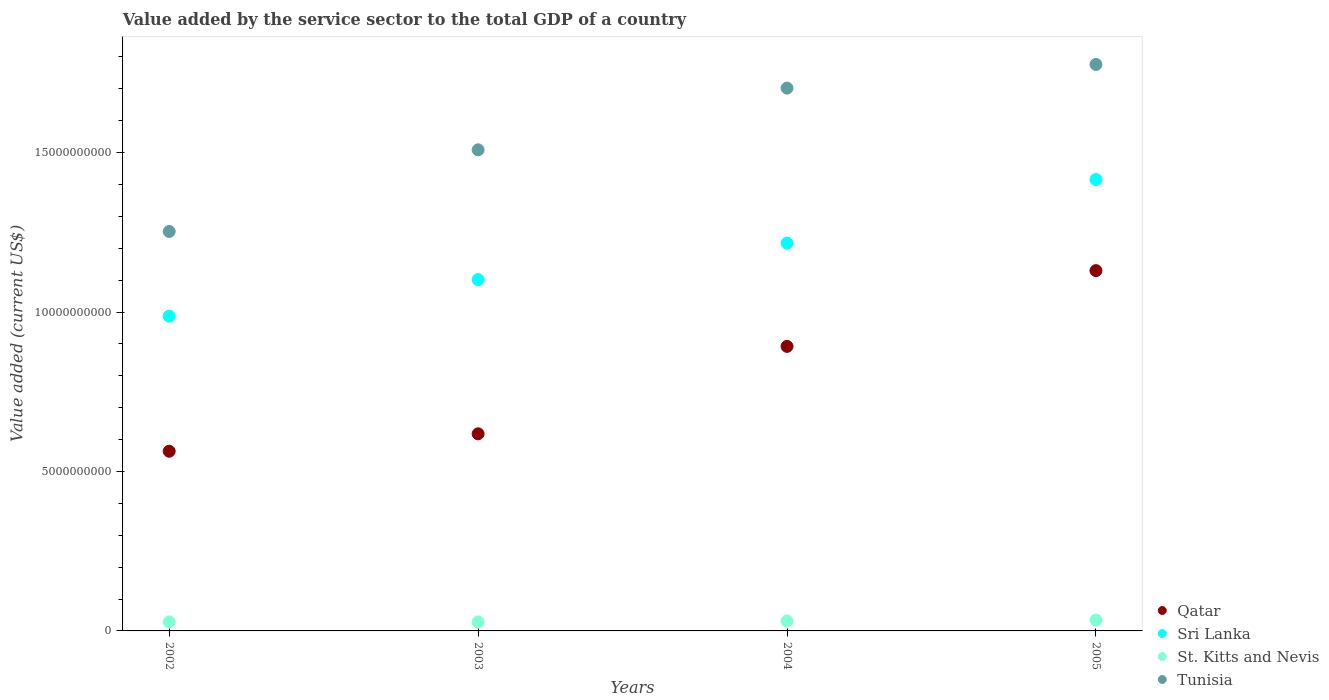How many different coloured dotlines are there?
Give a very brief answer. 4. What is the value added by the service sector to the total GDP in Sri Lanka in 2004?
Provide a succinct answer. 1.22e+1. Across all years, what is the maximum value added by the service sector to the total GDP in Qatar?
Your answer should be very brief. 1.13e+1. Across all years, what is the minimum value added by the service sector to the total GDP in St. Kitts and Nevis?
Make the answer very short. 2.83e+08. In which year was the value added by the service sector to the total GDP in St. Kitts and Nevis minimum?
Keep it short and to the point. 2002. What is the total value added by the service sector to the total GDP in Sri Lanka in the graph?
Your response must be concise. 4.72e+1. What is the difference between the value added by the service sector to the total GDP in St. Kitts and Nevis in 2004 and that in 2005?
Your answer should be compact. -2.75e+07. What is the difference between the value added by the service sector to the total GDP in Tunisia in 2004 and the value added by the service sector to the total GDP in Qatar in 2003?
Give a very brief answer. 1.08e+1. What is the average value added by the service sector to the total GDP in Sri Lanka per year?
Keep it short and to the point. 1.18e+1. In the year 2004, what is the difference between the value added by the service sector to the total GDP in St. Kitts and Nevis and value added by the service sector to the total GDP in Tunisia?
Offer a terse response. -1.67e+1. In how many years, is the value added by the service sector to the total GDP in St. Kitts and Nevis greater than 8000000000 US$?
Keep it short and to the point. 0. What is the ratio of the value added by the service sector to the total GDP in Sri Lanka in 2003 to that in 2005?
Your answer should be compact. 0.78. Is the value added by the service sector to the total GDP in Qatar in 2002 less than that in 2005?
Provide a short and direct response. Yes. What is the difference between the highest and the second highest value added by the service sector to the total GDP in St. Kitts and Nevis?
Your response must be concise. 2.75e+07. What is the difference between the highest and the lowest value added by the service sector to the total GDP in Qatar?
Make the answer very short. 5.66e+09. In how many years, is the value added by the service sector to the total GDP in Tunisia greater than the average value added by the service sector to the total GDP in Tunisia taken over all years?
Make the answer very short. 2. Is the value added by the service sector to the total GDP in Qatar strictly less than the value added by the service sector to the total GDP in Tunisia over the years?
Give a very brief answer. Yes. How many years are there in the graph?
Ensure brevity in your answer.  4. Does the graph contain any zero values?
Your answer should be compact. No. Does the graph contain grids?
Ensure brevity in your answer.  No. Where does the legend appear in the graph?
Your answer should be compact. Bottom right. How many legend labels are there?
Keep it short and to the point. 4. How are the legend labels stacked?
Offer a terse response. Vertical. What is the title of the graph?
Your answer should be compact. Value added by the service sector to the total GDP of a country. What is the label or title of the X-axis?
Your response must be concise. Years. What is the label or title of the Y-axis?
Ensure brevity in your answer.  Value added (current US$). What is the Value added (current US$) of Qatar in 2002?
Provide a succinct answer. 5.63e+09. What is the Value added (current US$) of Sri Lanka in 2002?
Your response must be concise. 9.87e+09. What is the Value added (current US$) in St. Kitts and Nevis in 2002?
Offer a very short reply. 2.83e+08. What is the Value added (current US$) of Tunisia in 2002?
Your response must be concise. 1.25e+1. What is the Value added (current US$) of Qatar in 2003?
Keep it short and to the point. 6.18e+09. What is the Value added (current US$) in Sri Lanka in 2003?
Keep it short and to the point. 1.10e+1. What is the Value added (current US$) in St. Kitts and Nevis in 2003?
Give a very brief answer. 2.83e+08. What is the Value added (current US$) in Tunisia in 2003?
Provide a succinct answer. 1.51e+1. What is the Value added (current US$) of Qatar in 2004?
Provide a short and direct response. 8.92e+09. What is the Value added (current US$) in Sri Lanka in 2004?
Provide a succinct answer. 1.22e+1. What is the Value added (current US$) of St. Kitts and Nevis in 2004?
Ensure brevity in your answer.  3.12e+08. What is the Value added (current US$) in Tunisia in 2004?
Offer a very short reply. 1.70e+1. What is the Value added (current US$) of Qatar in 2005?
Give a very brief answer. 1.13e+1. What is the Value added (current US$) in Sri Lanka in 2005?
Keep it short and to the point. 1.42e+1. What is the Value added (current US$) in St. Kitts and Nevis in 2005?
Offer a terse response. 3.39e+08. What is the Value added (current US$) of Tunisia in 2005?
Provide a short and direct response. 1.78e+1. Across all years, what is the maximum Value added (current US$) in Qatar?
Give a very brief answer. 1.13e+1. Across all years, what is the maximum Value added (current US$) in Sri Lanka?
Offer a very short reply. 1.42e+1. Across all years, what is the maximum Value added (current US$) of St. Kitts and Nevis?
Keep it short and to the point. 3.39e+08. Across all years, what is the maximum Value added (current US$) in Tunisia?
Keep it short and to the point. 1.78e+1. Across all years, what is the minimum Value added (current US$) of Qatar?
Give a very brief answer. 5.63e+09. Across all years, what is the minimum Value added (current US$) of Sri Lanka?
Offer a very short reply. 9.87e+09. Across all years, what is the minimum Value added (current US$) of St. Kitts and Nevis?
Your answer should be very brief. 2.83e+08. Across all years, what is the minimum Value added (current US$) of Tunisia?
Your answer should be compact. 1.25e+1. What is the total Value added (current US$) in Qatar in the graph?
Offer a very short reply. 3.20e+1. What is the total Value added (current US$) in Sri Lanka in the graph?
Provide a succinct answer. 4.72e+1. What is the total Value added (current US$) in St. Kitts and Nevis in the graph?
Your response must be concise. 1.22e+09. What is the total Value added (current US$) in Tunisia in the graph?
Make the answer very short. 6.24e+1. What is the difference between the Value added (current US$) of Qatar in 2002 and that in 2003?
Give a very brief answer. -5.47e+08. What is the difference between the Value added (current US$) in Sri Lanka in 2002 and that in 2003?
Offer a very short reply. -1.15e+09. What is the difference between the Value added (current US$) of St. Kitts and Nevis in 2002 and that in 2003?
Your answer should be compact. -1.73e+05. What is the difference between the Value added (current US$) in Tunisia in 2002 and that in 2003?
Keep it short and to the point. -2.56e+09. What is the difference between the Value added (current US$) in Qatar in 2002 and that in 2004?
Make the answer very short. -3.29e+09. What is the difference between the Value added (current US$) in Sri Lanka in 2002 and that in 2004?
Keep it short and to the point. -2.29e+09. What is the difference between the Value added (current US$) of St. Kitts and Nevis in 2002 and that in 2004?
Your answer should be very brief. -2.91e+07. What is the difference between the Value added (current US$) of Tunisia in 2002 and that in 2004?
Offer a very short reply. -4.50e+09. What is the difference between the Value added (current US$) in Qatar in 2002 and that in 2005?
Make the answer very short. -5.66e+09. What is the difference between the Value added (current US$) of Sri Lanka in 2002 and that in 2005?
Offer a terse response. -4.28e+09. What is the difference between the Value added (current US$) in St. Kitts and Nevis in 2002 and that in 2005?
Your answer should be very brief. -5.65e+07. What is the difference between the Value added (current US$) in Tunisia in 2002 and that in 2005?
Keep it short and to the point. -5.24e+09. What is the difference between the Value added (current US$) in Qatar in 2003 and that in 2004?
Your answer should be very brief. -2.74e+09. What is the difference between the Value added (current US$) of Sri Lanka in 2003 and that in 2004?
Make the answer very short. -1.14e+09. What is the difference between the Value added (current US$) of St. Kitts and Nevis in 2003 and that in 2004?
Your response must be concise. -2.89e+07. What is the difference between the Value added (current US$) in Tunisia in 2003 and that in 2004?
Your answer should be very brief. -1.94e+09. What is the difference between the Value added (current US$) in Qatar in 2003 and that in 2005?
Offer a very short reply. -5.12e+09. What is the difference between the Value added (current US$) in Sri Lanka in 2003 and that in 2005?
Give a very brief answer. -3.14e+09. What is the difference between the Value added (current US$) of St. Kitts and Nevis in 2003 and that in 2005?
Provide a succinct answer. -5.64e+07. What is the difference between the Value added (current US$) in Tunisia in 2003 and that in 2005?
Give a very brief answer. -2.68e+09. What is the difference between the Value added (current US$) of Qatar in 2004 and that in 2005?
Provide a short and direct response. -2.38e+09. What is the difference between the Value added (current US$) of Sri Lanka in 2004 and that in 2005?
Your answer should be compact. -2.00e+09. What is the difference between the Value added (current US$) of St. Kitts and Nevis in 2004 and that in 2005?
Provide a short and direct response. -2.75e+07. What is the difference between the Value added (current US$) in Tunisia in 2004 and that in 2005?
Your answer should be compact. -7.42e+08. What is the difference between the Value added (current US$) in Qatar in 2002 and the Value added (current US$) in Sri Lanka in 2003?
Give a very brief answer. -5.38e+09. What is the difference between the Value added (current US$) of Qatar in 2002 and the Value added (current US$) of St. Kitts and Nevis in 2003?
Provide a short and direct response. 5.35e+09. What is the difference between the Value added (current US$) of Qatar in 2002 and the Value added (current US$) of Tunisia in 2003?
Your answer should be very brief. -9.45e+09. What is the difference between the Value added (current US$) of Sri Lanka in 2002 and the Value added (current US$) of St. Kitts and Nevis in 2003?
Your response must be concise. 9.59e+09. What is the difference between the Value added (current US$) in Sri Lanka in 2002 and the Value added (current US$) in Tunisia in 2003?
Your answer should be compact. -5.22e+09. What is the difference between the Value added (current US$) of St. Kitts and Nevis in 2002 and the Value added (current US$) of Tunisia in 2003?
Your answer should be compact. -1.48e+1. What is the difference between the Value added (current US$) in Qatar in 2002 and the Value added (current US$) in Sri Lanka in 2004?
Give a very brief answer. -6.52e+09. What is the difference between the Value added (current US$) of Qatar in 2002 and the Value added (current US$) of St. Kitts and Nevis in 2004?
Ensure brevity in your answer.  5.32e+09. What is the difference between the Value added (current US$) of Qatar in 2002 and the Value added (current US$) of Tunisia in 2004?
Keep it short and to the point. -1.14e+1. What is the difference between the Value added (current US$) in Sri Lanka in 2002 and the Value added (current US$) in St. Kitts and Nevis in 2004?
Make the answer very short. 9.56e+09. What is the difference between the Value added (current US$) of Sri Lanka in 2002 and the Value added (current US$) of Tunisia in 2004?
Your answer should be compact. -7.15e+09. What is the difference between the Value added (current US$) of St. Kitts and Nevis in 2002 and the Value added (current US$) of Tunisia in 2004?
Provide a succinct answer. -1.67e+1. What is the difference between the Value added (current US$) in Qatar in 2002 and the Value added (current US$) in Sri Lanka in 2005?
Offer a terse response. -8.52e+09. What is the difference between the Value added (current US$) in Qatar in 2002 and the Value added (current US$) in St. Kitts and Nevis in 2005?
Provide a short and direct response. 5.29e+09. What is the difference between the Value added (current US$) in Qatar in 2002 and the Value added (current US$) in Tunisia in 2005?
Provide a short and direct response. -1.21e+1. What is the difference between the Value added (current US$) of Sri Lanka in 2002 and the Value added (current US$) of St. Kitts and Nevis in 2005?
Provide a short and direct response. 9.53e+09. What is the difference between the Value added (current US$) in Sri Lanka in 2002 and the Value added (current US$) in Tunisia in 2005?
Your response must be concise. -7.89e+09. What is the difference between the Value added (current US$) in St. Kitts and Nevis in 2002 and the Value added (current US$) in Tunisia in 2005?
Your response must be concise. -1.75e+1. What is the difference between the Value added (current US$) in Qatar in 2003 and the Value added (current US$) in Sri Lanka in 2004?
Ensure brevity in your answer.  -5.98e+09. What is the difference between the Value added (current US$) of Qatar in 2003 and the Value added (current US$) of St. Kitts and Nevis in 2004?
Keep it short and to the point. 5.87e+09. What is the difference between the Value added (current US$) in Qatar in 2003 and the Value added (current US$) in Tunisia in 2004?
Offer a very short reply. -1.08e+1. What is the difference between the Value added (current US$) of Sri Lanka in 2003 and the Value added (current US$) of St. Kitts and Nevis in 2004?
Give a very brief answer. 1.07e+1. What is the difference between the Value added (current US$) of Sri Lanka in 2003 and the Value added (current US$) of Tunisia in 2004?
Your answer should be very brief. -6.00e+09. What is the difference between the Value added (current US$) in St. Kitts and Nevis in 2003 and the Value added (current US$) in Tunisia in 2004?
Offer a very short reply. -1.67e+1. What is the difference between the Value added (current US$) of Qatar in 2003 and the Value added (current US$) of Sri Lanka in 2005?
Provide a short and direct response. -7.97e+09. What is the difference between the Value added (current US$) in Qatar in 2003 and the Value added (current US$) in St. Kitts and Nevis in 2005?
Offer a very short reply. 5.84e+09. What is the difference between the Value added (current US$) in Qatar in 2003 and the Value added (current US$) in Tunisia in 2005?
Offer a terse response. -1.16e+1. What is the difference between the Value added (current US$) in Sri Lanka in 2003 and the Value added (current US$) in St. Kitts and Nevis in 2005?
Your answer should be compact. 1.07e+1. What is the difference between the Value added (current US$) of Sri Lanka in 2003 and the Value added (current US$) of Tunisia in 2005?
Give a very brief answer. -6.75e+09. What is the difference between the Value added (current US$) of St. Kitts and Nevis in 2003 and the Value added (current US$) of Tunisia in 2005?
Make the answer very short. -1.75e+1. What is the difference between the Value added (current US$) in Qatar in 2004 and the Value added (current US$) in Sri Lanka in 2005?
Provide a short and direct response. -5.23e+09. What is the difference between the Value added (current US$) of Qatar in 2004 and the Value added (current US$) of St. Kitts and Nevis in 2005?
Your answer should be very brief. 8.58e+09. What is the difference between the Value added (current US$) of Qatar in 2004 and the Value added (current US$) of Tunisia in 2005?
Make the answer very short. -8.84e+09. What is the difference between the Value added (current US$) of Sri Lanka in 2004 and the Value added (current US$) of St. Kitts and Nevis in 2005?
Make the answer very short. 1.18e+1. What is the difference between the Value added (current US$) in Sri Lanka in 2004 and the Value added (current US$) in Tunisia in 2005?
Your response must be concise. -5.61e+09. What is the difference between the Value added (current US$) of St. Kitts and Nevis in 2004 and the Value added (current US$) of Tunisia in 2005?
Your response must be concise. -1.75e+1. What is the average Value added (current US$) of Qatar per year?
Provide a succinct answer. 8.01e+09. What is the average Value added (current US$) of Sri Lanka per year?
Offer a very short reply. 1.18e+1. What is the average Value added (current US$) of St. Kitts and Nevis per year?
Give a very brief answer. 3.04e+08. What is the average Value added (current US$) of Tunisia per year?
Offer a terse response. 1.56e+1. In the year 2002, what is the difference between the Value added (current US$) of Qatar and Value added (current US$) of Sri Lanka?
Your answer should be compact. -4.24e+09. In the year 2002, what is the difference between the Value added (current US$) of Qatar and Value added (current US$) of St. Kitts and Nevis?
Your response must be concise. 5.35e+09. In the year 2002, what is the difference between the Value added (current US$) of Qatar and Value added (current US$) of Tunisia?
Offer a very short reply. -6.89e+09. In the year 2002, what is the difference between the Value added (current US$) of Sri Lanka and Value added (current US$) of St. Kitts and Nevis?
Keep it short and to the point. 9.59e+09. In the year 2002, what is the difference between the Value added (current US$) of Sri Lanka and Value added (current US$) of Tunisia?
Provide a short and direct response. -2.66e+09. In the year 2002, what is the difference between the Value added (current US$) in St. Kitts and Nevis and Value added (current US$) in Tunisia?
Offer a very short reply. -1.22e+1. In the year 2003, what is the difference between the Value added (current US$) in Qatar and Value added (current US$) in Sri Lanka?
Provide a succinct answer. -4.84e+09. In the year 2003, what is the difference between the Value added (current US$) of Qatar and Value added (current US$) of St. Kitts and Nevis?
Offer a terse response. 5.90e+09. In the year 2003, what is the difference between the Value added (current US$) in Qatar and Value added (current US$) in Tunisia?
Your answer should be compact. -8.90e+09. In the year 2003, what is the difference between the Value added (current US$) of Sri Lanka and Value added (current US$) of St. Kitts and Nevis?
Your answer should be compact. 1.07e+1. In the year 2003, what is the difference between the Value added (current US$) of Sri Lanka and Value added (current US$) of Tunisia?
Your answer should be very brief. -4.07e+09. In the year 2003, what is the difference between the Value added (current US$) of St. Kitts and Nevis and Value added (current US$) of Tunisia?
Make the answer very short. -1.48e+1. In the year 2004, what is the difference between the Value added (current US$) in Qatar and Value added (current US$) in Sri Lanka?
Offer a very short reply. -3.24e+09. In the year 2004, what is the difference between the Value added (current US$) of Qatar and Value added (current US$) of St. Kitts and Nevis?
Give a very brief answer. 8.61e+09. In the year 2004, what is the difference between the Value added (current US$) of Qatar and Value added (current US$) of Tunisia?
Your answer should be compact. -8.10e+09. In the year 2004, what is the difference between the Value added (current US$) in Sri Lanka and Value added (current US$) in St. Kitts and Nevis?
Provide a succinct answer. 1.18e+1. In the year 2004, what is the difference between the Value added (current US$) of Sri Lanka and Value added (current US$) of Tunisia?
Offer a very short reply. -4.86e+09. In the year 2004, what is the difference between the Value added (current US$) in St. Kitts and Nevis and Value added (current US$) in Tunisia?
Make the answer very short. -1.67e+1. In the year 2005, what is the difference between the Value added (current US$) in Qatar and Value added (current US$) in Sri Lanka?
Keep it short and to the point. -2.86e+09. In the year 2005, what is the difference between the Value added (current US$) of Qatar and Value added (current US$) of St. Kitts and Nevis?
Provide a succinct answer. 1.10e+1. In the year 2005, what is the difference between the Value added (current US$) in Qatar and Value added (current US$) in Tunisia?
Ensure brevity in your answer.  -6.47e+09. In the year 2005, what is the difference between the Value added (current US$) in Sri Lanka and Value added (current US$) in St. Kitts and Nevis?
Ensure brevity in your answer.  1.38e+1. In the year 2005, what is the difference between the Value added (current US$) of Sri Lanka and Value added (current US$) of Tunisia?
Offer a terse response. -3.61e+09. In the year 2005, what is the difference between the Value added (current US$) in St. Kitts and Nevis and Value added (current US$) in Tunisia?
Provide a succinct answer. -1.74e+1. What is the ratio of the Value added (current US$) in Qatar in 2002 to that in 2003?
Your response must be concise. 0.91. What is the ratio of the Value added (current US$) of Sri Lanka in 2002 to that in 2003?
Keep it short and to the point. 0.9. What is the ratio of the Value added (current US$) in St. Kitts and Nevis in 2002 to that in 2003?
Offer a terse response. 1. What is the ratio of the Value added (current US$) in Tunisia in 2002 to that in 2003?
Make the answer very short. 0.83. What is the ratio of the Value added (current US$) in Qatar in 2002 to that in 2004?
Give a very brief answer. 0.63. What is the ratio of the Value added (current US$) in Sri Lanka in 2002 to that in 2004?
Your answer should be very brief. 0.81. What is the ratio of the Value added (current US$) of St. Kitts and Nevis in 2002 to that in 2004?
Offer a very short reply. 0.91. What is the ratio of the Value added (current US$) in Tunisia in 2002 to that in 2004?
Provide a succinct answer. 0.74. What is the ratio of the Value added (current US$) of Qatar in 2002 to that in 2005?
Make the answer very short. 0.5. What is the ratio of the Value added (current US$) in Sri Lanka in 2002 to that in 2005?
Keep it short and to the point. 0.7. What is the ratio of the Value added (current US$) of St. Kitts and Nevis in 2002 to that in 2005?
Provide a succinct answer. 0.83. What is the ratio of the Value added (current US$) in Tunisia in 2002 to that in 2005?
Keep it short and to the point. 0.71. What is the ratio of the Value added (current US$) of Qatar in 2003 to that in 2004?
Provide a short and direct response. 0.69. What is the ratio of the Value added (current US$) in Sri Lanka in 2003 to that in 2004?
Your answer should be very brief. 0.91. What is the ratio of the Value added (current US$) in St. Kitts and Nevis in 2003 to that in 2004?
Provide a short and direct response. 0.91. What is the ratio of the Value added (current US$) in Tunisia in 2003 to that in 2004?
Your answer should be very brief. 0.89. What is the ratio of the Value added (current US$) in Qatar in 2003 to that in 2005?
Keep it short and to the point. 0.55. What is the ratio of the Value added (current US$) in Sri Lanka in 2003 to that in 2005?
Offer a very short reply. 0.78. What is the ratio of the Value added (current US$) in St. Kitts and Nevis in 2003 to that in 2005?
Offer a terse response. 0.83. What is the ratio of the Value added (current US$) of Tunisia in 2003 to that in 2005?
Give a very brief answer. 0.85. What is the ratio of the Value added (current US$) in Qatar in 2004 to that in 2005?
Make the answer very short. 0.79. What is the ratio of the Value added (current US$) of Sri Lanka in 2004 to that in 2005?
Make the answer very short. 0.86. What is the ratio of the Value added (current US$) of St. Kitts and Nevis in 2004 to that in 2005?
Your answer should be very brief. 0.92. What is the ratio of the Value added (current US$) of Tunisia in 2004 to that in 2005?
Make the answer very short. 0.96. What is the difference between the highest and the second highest Value added (current US$) in Qatar?
Offer a very short reply. 2.38e+09. What is the difference between the highest and the second highest Value added (current US$) of Sri Lanka?
Offer a terse response. 2.00e+09. What is the difference between the highest and the second highest Value added (current US$) in St. Kitts and Nevis?
Ensure brevity in your answer.  2.75e+07. What is the difference between the highest and the second highest Value added (current US$) in Tunisia?
Provide a short and direct response. 7.42e+08. What is the difference between the highest and the lowest Value added (current US$) of Qatar?
Your answer should be very brief. 5.66e+09. What is the difference between the highest and the lowest Value added (current US$) of Sri Lanka?
Keep it short and to the point. 4.28e+09. What is the difference between the highest and the lowest Value added (current US$) in St. Kitts and Nevis?
Ensure brevity in your answer.  5.65e+07. What is the difference between the highest and the lowest Value added (current US$) of Tunisia?
Your answer should be compact. 5.24e+09. 